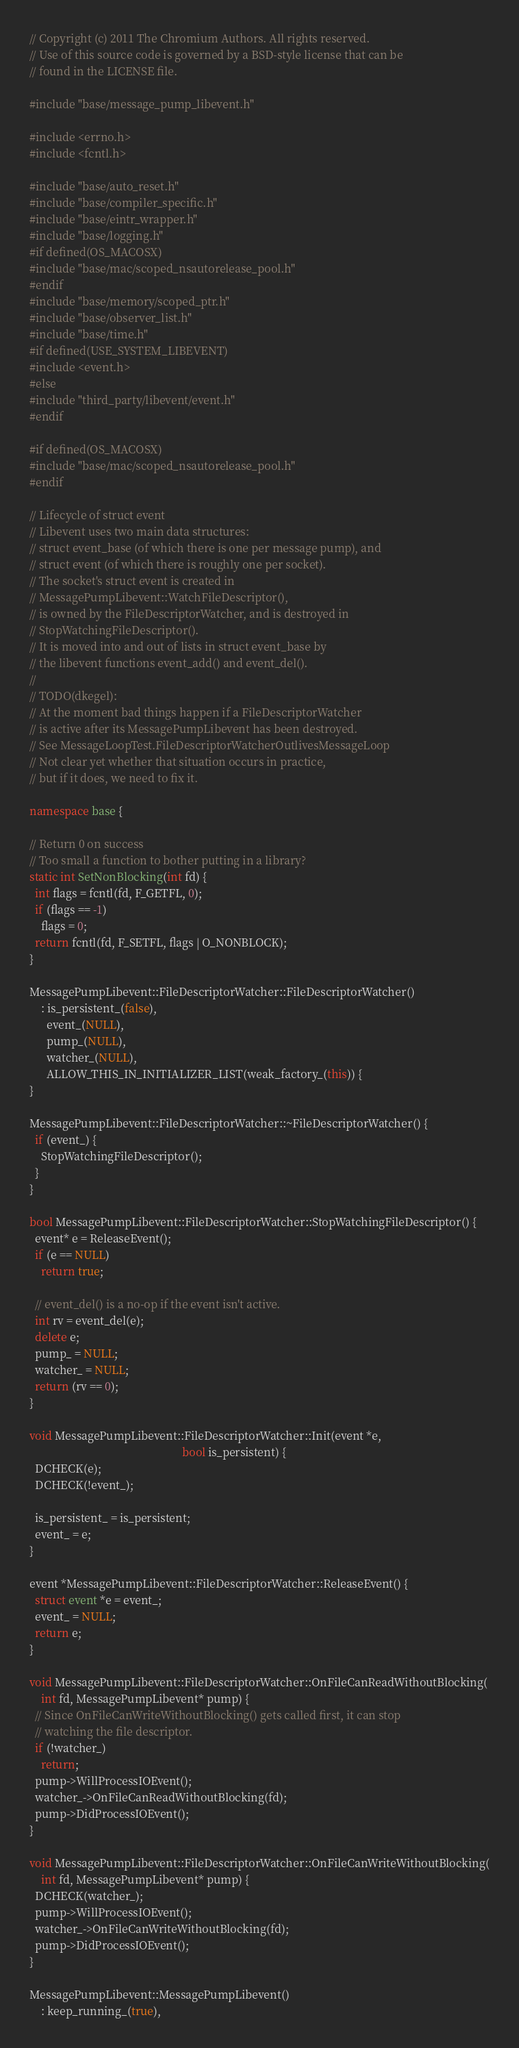Convert code to text. <code><loc_0><loc_0><loc_500><loc_500><_C++_>// Copyright (c) 2011 The Chromium Authors. All rights reserved.
// Use of this source code is governed by a BSD-style license that can be
// found in the LICENSE file.

#include "base/message_pump_libevent.h"

#include <errno.h>
#include <fcntl.h>

#include "base/auto_reset.h"
#include "base/compiler_specific.h"
#include "base/eintr_wrapper.h"
#include "base/logging.h"
#if defined(OS_MACOSX)
#include "base/mac/scoped_nsautorelease_pool.h"
#endif
#include "base/memory/scoped_ptr.h"
#include "base/observer_list.h"
#include "base/time.h"
#if defined(USE_SYSTEM_LIBEVENT)
#include <event.h>
#else
#include "third_party/libevent/event.h"
#endif

#if defined(OS_MACOSX)
#include "base/mac/scoped_nsautorelease_pool.h"
#endif

// Lifecycle of struct event
// Libevent uses two main data structures:
// struct event_base (of which there is one per message pump), and
// struct event (of which there is roughly one per socket).
// The socket's struct event is created in
// MessagePumpLibevent::WatchFileDescriptor(),
// is owned by the FileDescriptorWatcher, and is destroyed in
// StopWatchingFileDescriptor().
// It is moved into and out of lists in struct event_base by
// the libevent functions event_add() and event_del().
//
// TODO(dkegel):
// At the moment bad things happen if a FileDescriptorWatcher
// is active after its MessagePumpLibevent has been destroyed.
// See MessageLoopTest.FileDescriptorWatcherOutlivesMessageLoop
// Not clear yet whether that situation occurs in practice,
// but if it does, we need to fix it.

namespace base {

// Return 0 on success
// Too small a function to bother putting in a library?
static int SetNonBlocking(int fd) {
  int flags = fcntl(fd, F_GETFL, 0);
  if (flags == -1)
    flags = 0;
  return fcntl(fd, F_SETFL, flags | O_NONBLOCK);
}

MessagePumpLibevent::FileDescriptorWatcher::FileDescriptorWatcher()
    : is_persistent_(false),
      event_(NULL),
      pump_(NULL),
      watcher_(NULL),
      ALLOW_THIS_IN_INITIALIZER_LIST(weak_factory_(this)) {
}

MessagePumpLibevent::FileDescriptorWatcher::~FileDescriptorWatcher() {
  if (event_) {
    StopWatchingFileDescriptor();
  }
}

bool MessagePumpLibevent::FileDescriptorWatcher::StopWatchingFileDescriptor() {
  event* e = ReleaseEvent();
  if (e == NULL)
    return true;

  // event_del() is a no-op if the event isn't active.
  int rv = event_del(e);
  delete e;
  pump_ = NULL;
  watcher_ = NULL;
  return (rv == 0);
}

void MessagePumpLibevent::FileDescriptorWatcher::Init(event *e,
                                                      bool is_persistent) {
  DCHECK(e);
  DCHECK(!event_);

  is_persistent_ = is_persistent;
  event_ = e;
}

event *MessagePumpLibevent::FileDescriptorWatcher::ReleaseEvent() {
  struct event *e = event_;
  event_ = NULL;
  return e;
}

void MessagePumpLibevent::FileDescriptorWatcher::OnFileCanReadWithoutBlocking(
    int fd, MessagePumpLibevent* pump) {
  // Since OnFileCanWriteWithoutBlocking() gets called first, it can stop
  // watching the file descriptor.
  if (!watcher_)
    return;
  pump->WillProcessIOEvent();
  watcher_->OnFileCanReadWithoutBlocking(fd);
  pump->DidProcessIOEvent();
}

void MessagePumpLibevent::FileDescriptorWatcher::OnFileCanWriteWithoutBlocking(
    int fd, MessagePumpLibevent* pump) {
  DCHECK(watcher_);
  pump->WillProcessIOEvent();
  watcher_->OnFileCanWriteWithoutBlocking(fd);
  pump->DidProcessIOEvent();
}

MessagePumpLibevent::MessagePumpLibevent()
    : keep_running_(true),</code> 